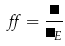<formula> <loc_0><loc_0><loc_500><loc_500>\alpha = \frac { \Lambda } { \Lambda _ { E } }</formula> 